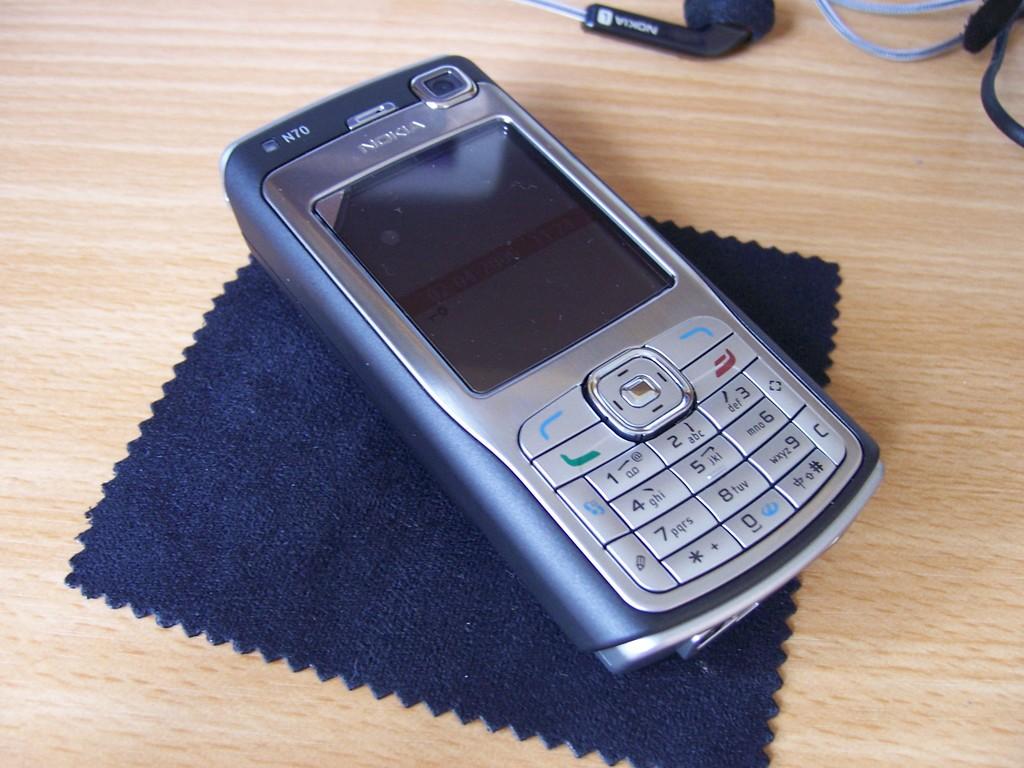Is the phone a nokia?
Give a very brief answer. Yes. What brand of phone is this?
Your response must be concise. Nokia. 